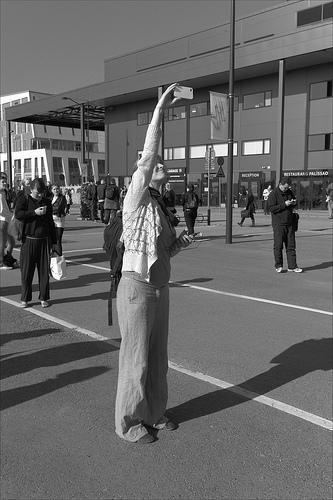How many phones is the woman holding?
Give a very brief answer. 1. 